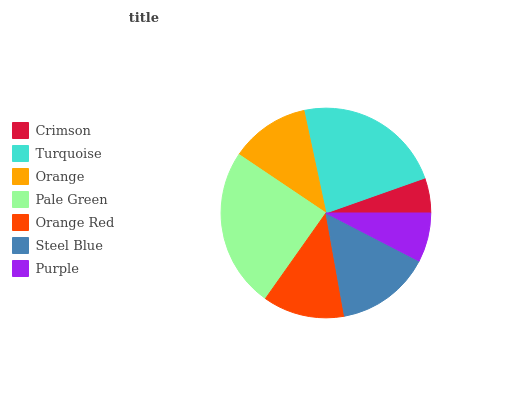Is Crimson the minimum?
Answer yes or no. Yes. Is Pale Green the maximum?
Answer yes or no. Yes. Is Turquoise the minimum?
Answer yes or no. No. Is Turquoise the maximum?
Answer yes or no. No. Is Turquoise greater than Crimson?
Answer yes or no. Yes. Is Crimson less than Turquoise?
Answer yes or no. Yes. Is Crimson greater than Turquoise?
Answer yes or no. No. Is Turquoise less than Crimson?
Answer yes or no. No. Is Orange Red the high median?
Answer yes or no. Yes. Is Orange Red the low median?
Answer yes or no. Yes. Is Pale Green the high median?
Answer yes or no. No. Is Steel Blue the low median?
Answer yes or no. No. 